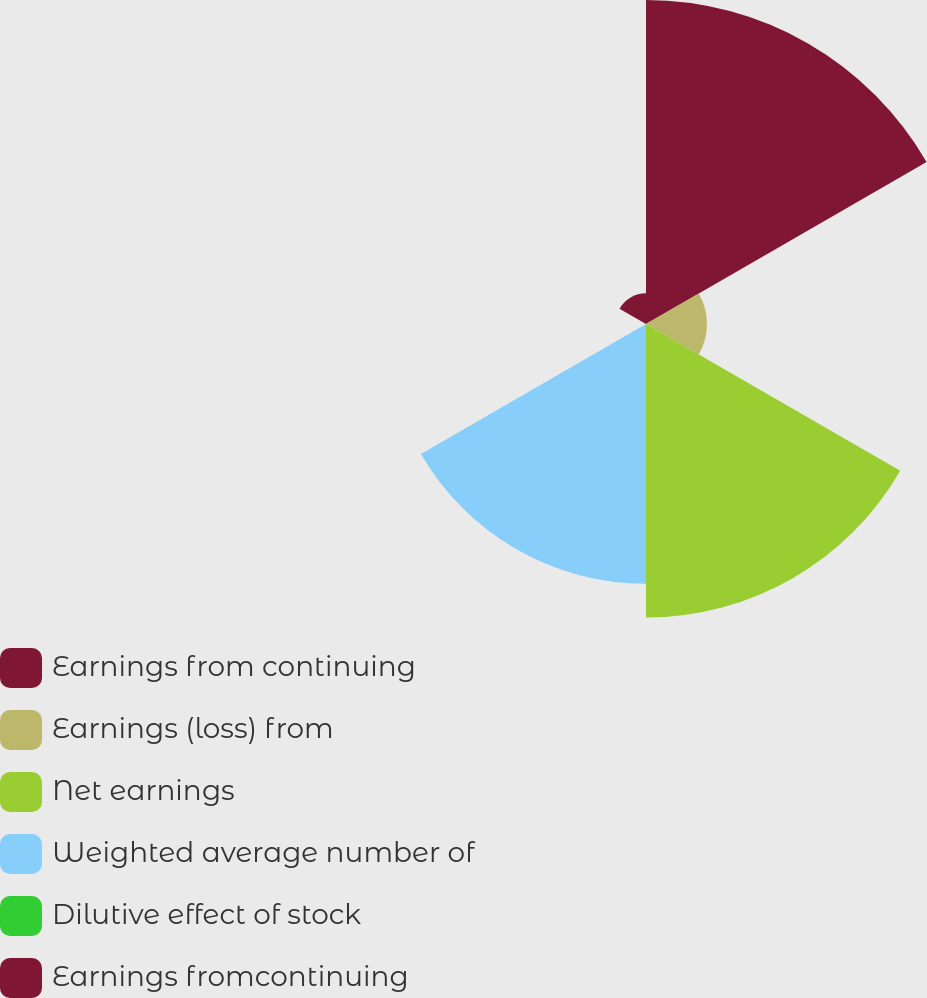Convert chart to OTSL. <chart><loc_0><loc_0><loc_500><loc_500><pie_chart><fcel>Earnings from continuing<fcel>Earnings (loss) from<fcel>Net earnings<fcel>Weighted average number of<fcel>Dilutive effect of stock<fcel>Earnings fromcontinuing<nl><fcel>33.43%<fcel>6.29%<fcel>30.29%<fcel>26.81%<fcel>0.02%<fcel>3.16%<nl></chart> 